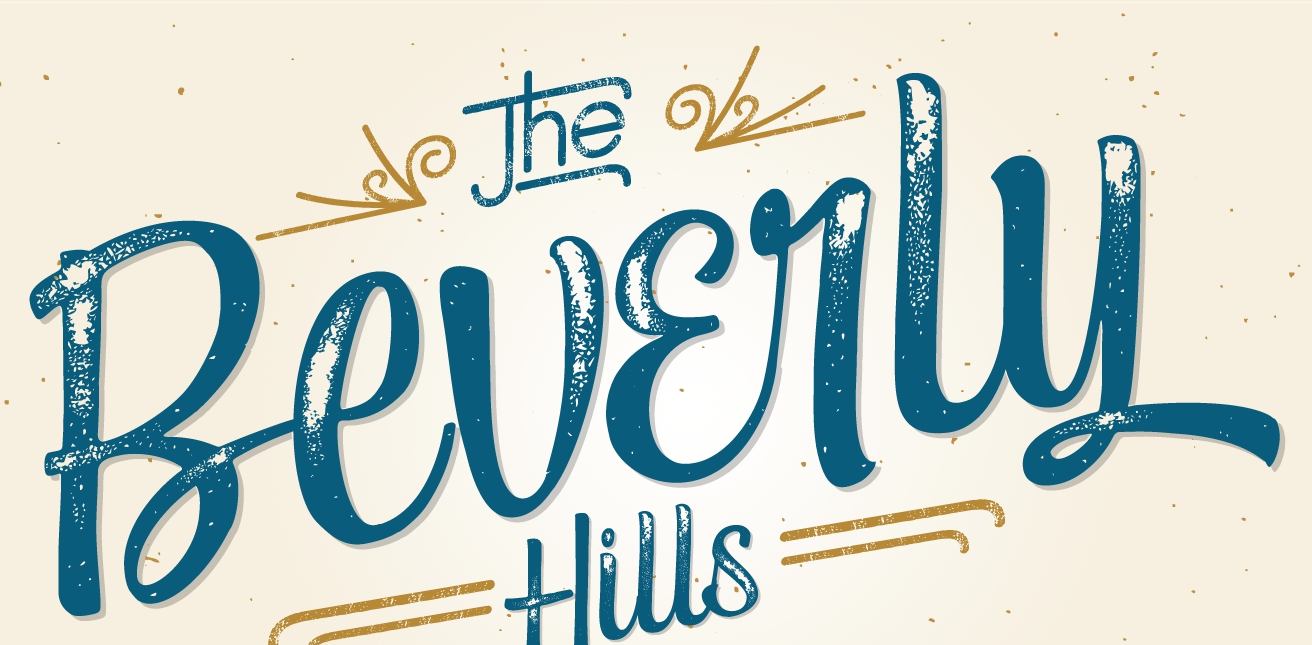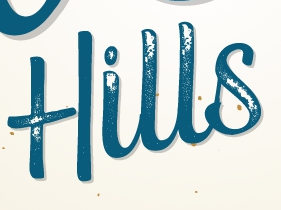What text appears in these images from left to right, separated by a semicolon? Beverly; Hills 